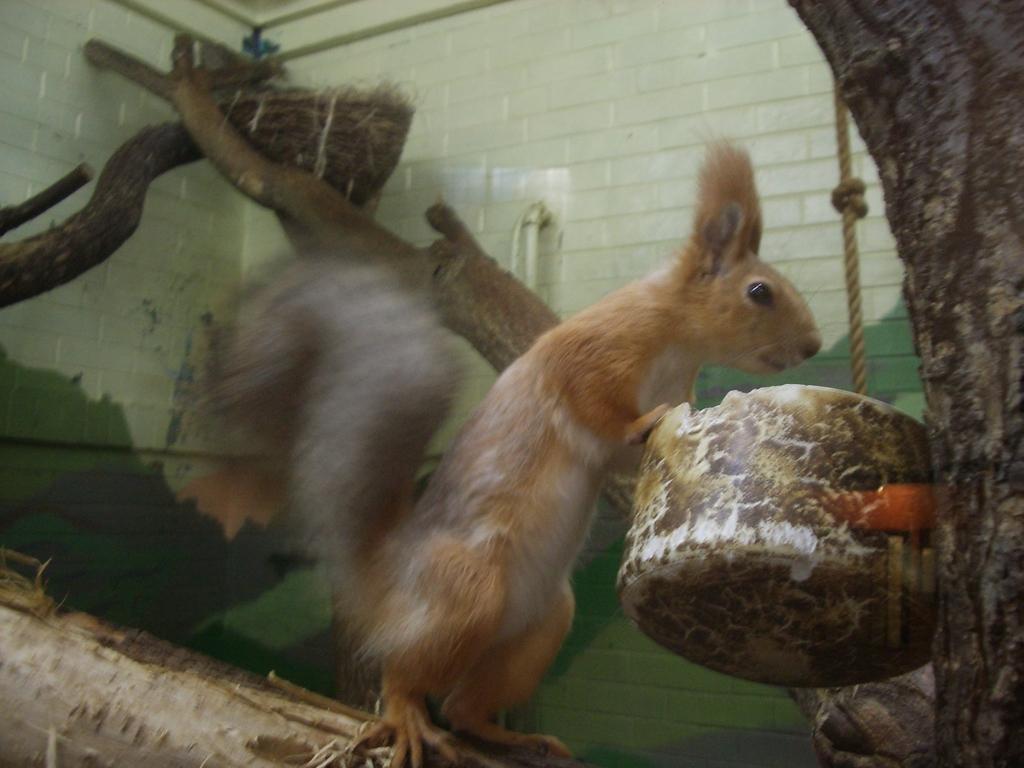Please provide a concise description of this image. In this image I can see a tree trunk, few branches and on the one branch I can see a cream colour squirrel. On the both sides of the image I can see two containers and on the right side I can see a rope. I can also see this image is little bit blurry. 